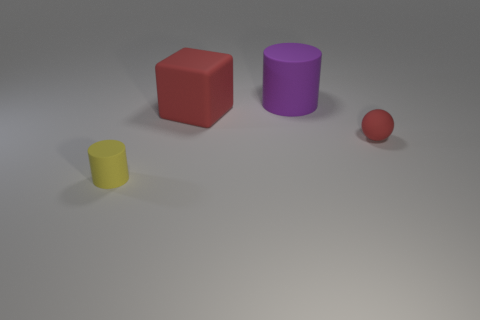The small yellow matte thing has what shape?
Your answer should be very brief. Cylinder. Does the cylinder right of the tiny yellow thing have the same size as the red thing to the left of the tiny rubber ball?
Your response must be concise. Yes. There is a cylinder that is in front of the ball right of the big thing left of the large purple cylinder; what size is it?
Ensure brevity in your answer.  Small. The tiny rubber object behind the cylinder on the left side of the large matte thing that is behind the big rubber cube is what shape?
Your answer should be very brief. Sphere. What is the shape of the small rubber thing that is left of the tiny red thing?
Provide a succinct answer. Cylinder. Is the big red thing made of the same material as the red object in front of the large red matte cube?
Your answer should be compact. Yes. What number of other things are there of the same shape as the purple thing?
Ensure brevity in your answer.  1. Does the large matte cube have the same color as the cylinder on the right side of the yellow cylinder?
Keep it short and to the point. No. Is there any other thing that has the same material as the tiny yellow thing?
Your answer should be very brief. Yes. There is a tiny thing to the right of the matte cylinder that is in front of the large red thing; what is its shape?
Ensure brevity in your answer.  Sphere. 